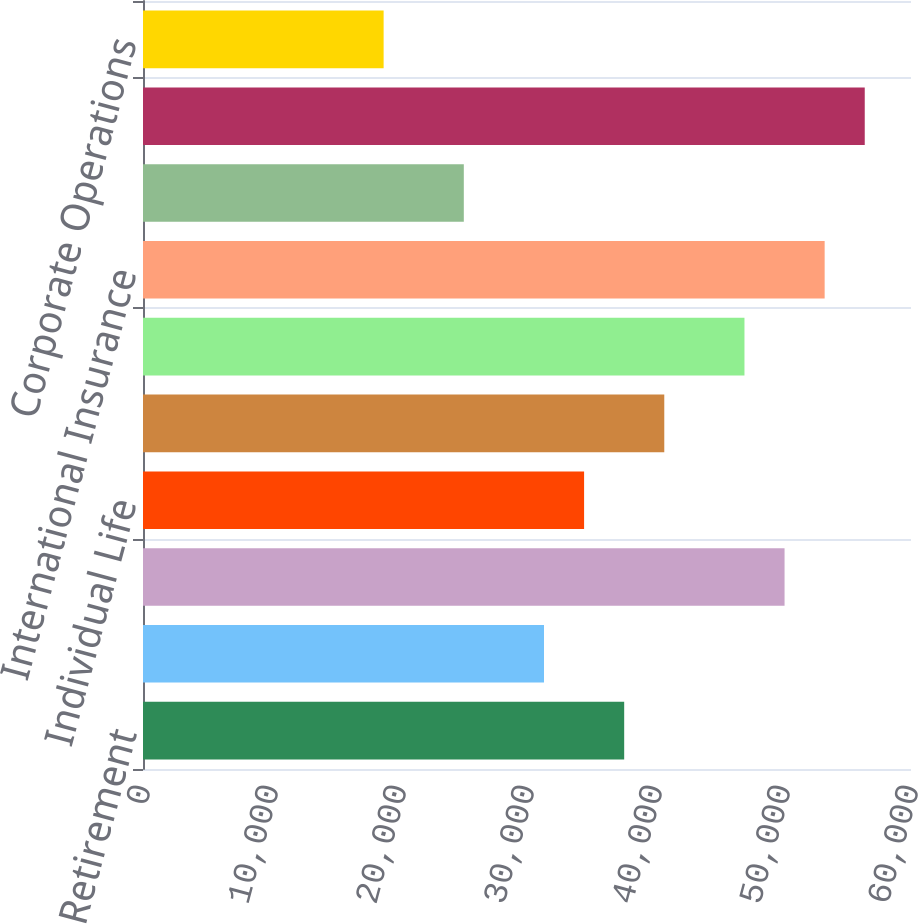Convert chart to OTSL. <chart><loc_0><loc_0><loc_500><loc_500><bar_chart><fcel>Retirement<fcel>Asset Management<fcel>Total US Retirement Solutions<fcel>Individual Life<fcel>Group Insurance<fcel>Total US Individual Life and<fcel>International Insurance<fcel>International Investments<fcel>Total International Insurance<fcel>Corporate Operations<nl><fcel>37592.7<fcel>31328<fcel>50121.9<fcel>34460.3<fcel>40725<fcel>46989.6<fcel>53254.3<fcel>25063.4<fcel>56386.6<fcel>18798.7<nl></chart> 